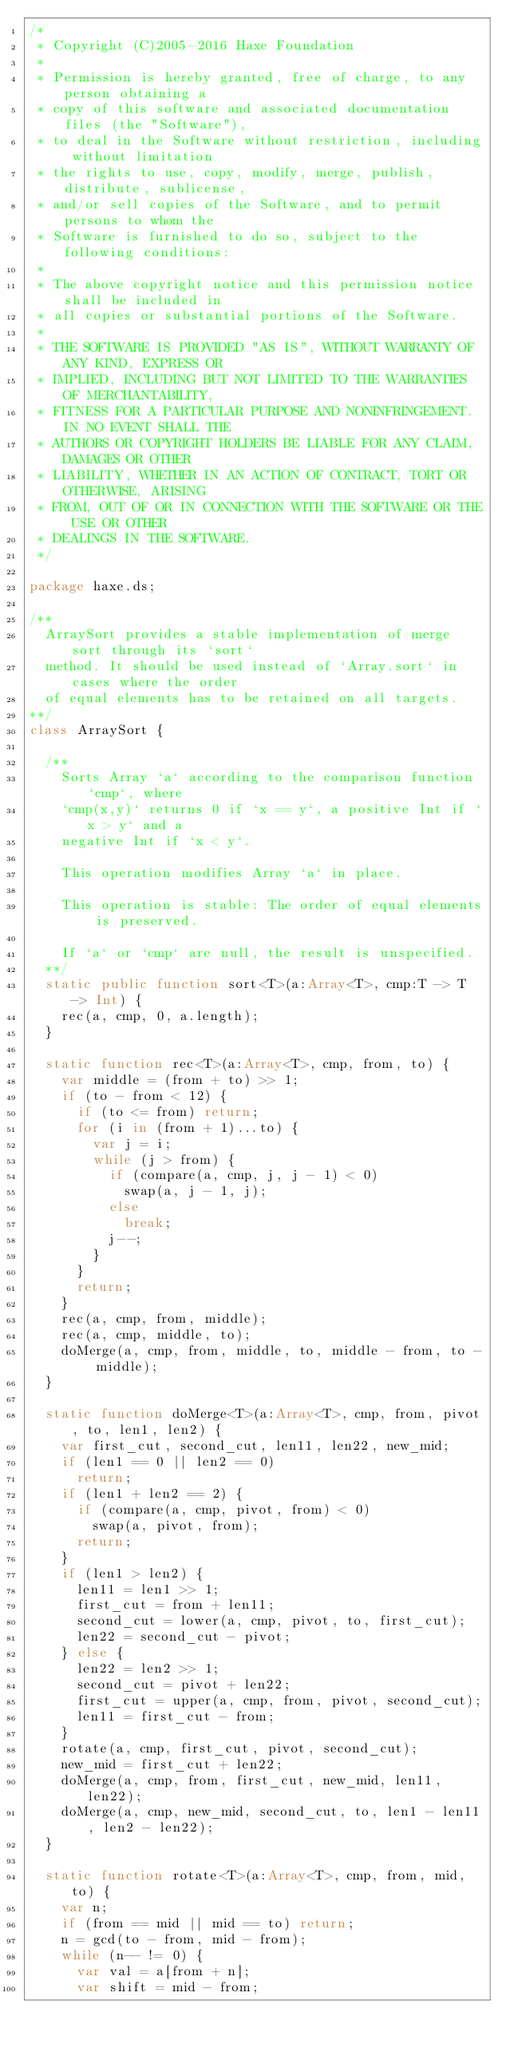<code> <loc_0><loc_0><loc_500><loc_500><_Haxe_>/*
 * Copyright (C)2005-2016 Haxe Foundation
 *
 * Permission is hereby granted, free of charge, to any person obtaining a
 * copy of this software and associated documentation files (the "Software"),
 * to deal in the Software without restriction, including without limitation
 * the rights to use, copy, modify, merge, publish, distribute, sublicense,
 * and/or sell copies of the Software, and to permit persons to whom the
 * Software is furnished to do so, subject to the following conditions:
 *
 * The above copyright notice and this permission notice shall be included in
 * all copies or substantial portions of the Software.
 *
 * THE SOFTWARE IS PROVIDED "AS IS", WITHOUT WARRANTY OF ANY KIND, EXPRESS OR
 * IMPLIED, INCLUDING BUT NOT LIMITED TO THE WARRANTIES OF MERCHANTABILITY,
 * FITNESS FOR A PARTICULAR PURPOSE AND NONINFRINGEMENT. IN NO EVENT SHALL THE
 * AUTHORS OR COPYRIGHT HOLDERS BE LIABLE FOR ANY CLAIM, DAMAGES OR OTHER
 * LIABILITY, WHETHER IN AN ACTION OF CONTRACT, TORT OR OTHERWISE, ARISING
 * FROM, OUT OF OR IN CONNECTION WITH THE SOFTWARE OR THE USE OR OTHER
 * DEALINGS IN THE SOFTWARE.
 */

package haxe.ds;

/**
	ArraySort provides a stable implementation of merge sort through its `sort`
	method. It should be used instead of `Array.sort` in cases where the order
	of equal elements has to be retained on all targets.
**/
class ArraySort {

	/**
		Sorts Array `a` according to the comparison function `cmp`, where
		`cmp(x,y)` returns 0 if `x == y`, a positive Int if `x > y` and a
		negative Int if `x < y`.

		This operation modifies Array `a` in place.

		This operation is stable: The order of equal elements is preserved.

		If `a` or `cmp` are null, the result is unspecified.
	**/
	static public function sort<T>(a:Array<T>, cmp:T -> T -> Int) {
		rec(a, cmp, 0, a.length);
	}

	static function rec<T>(a:Array<T>, cmp, from, to) {
		var middle = (from + to) >> 1;
		if (to - from < 12) {
			if (to <= from) return;
			for (i in (from + 1)...to) {
				var j = i;
				while (j > from) {
					if (compare(a, cmp, j, j - 1) < 0)
						swap(a, j - 1, j);
					else
						break;
					j--;
				}
			}
			return;
		}
		rec(a, cmp, from, middle);
		rec(a, cmp, middle, to);
		doMerge(a, cmp, from, middle, to, middle - from, to - middle);
	}

	static function doMerge<T>(a:Array<T>, cmp, from, pivot, to, len1, len2) {
		var first_cut, second_cut, len11, len22, new_mid;
		if (len1 == 0 || len2 == 0)
			return;
		if (len1 + len2 == 2) {
			if (compare(a, cmp, pivot, from) < 0)
				swap(a, pivot, from);
			return;
		}
		if (len1 > len2) {
			len11 = len1 >> 1;
			first_cut = from + len11;
			second_cut = lower(a, cmp, pivot, to, first_cut);
			len22 = second_cut - pivot;
		} else {
			len22 = len2 >> 1;
			second_cut = pivot + len22;
			first_cut = upper(a, cmp, from, pivot, second_cut);
			len11 = first_cut - from;
		}
		rotate(a, cmp, first_cut, pivot, second_cut);
		new_mid = first_cut + len22;
		doMerge(a, cmp, from, first_cut, new_mid, len11, len22);
		doMerge(a, cmp, new_mid, second_cut, to, len1 - len11, len2 - len22);
	}

	static function rotate<T>(a:Array<T>, cmp, from, mid, to) {
		var n;
		if (from == mid || mid == to) return;
		n = gcd(to - from, mid - from);
		while (n-- != 0) {
			var val = a[from + n];
			var shift = mid - from;</code> 